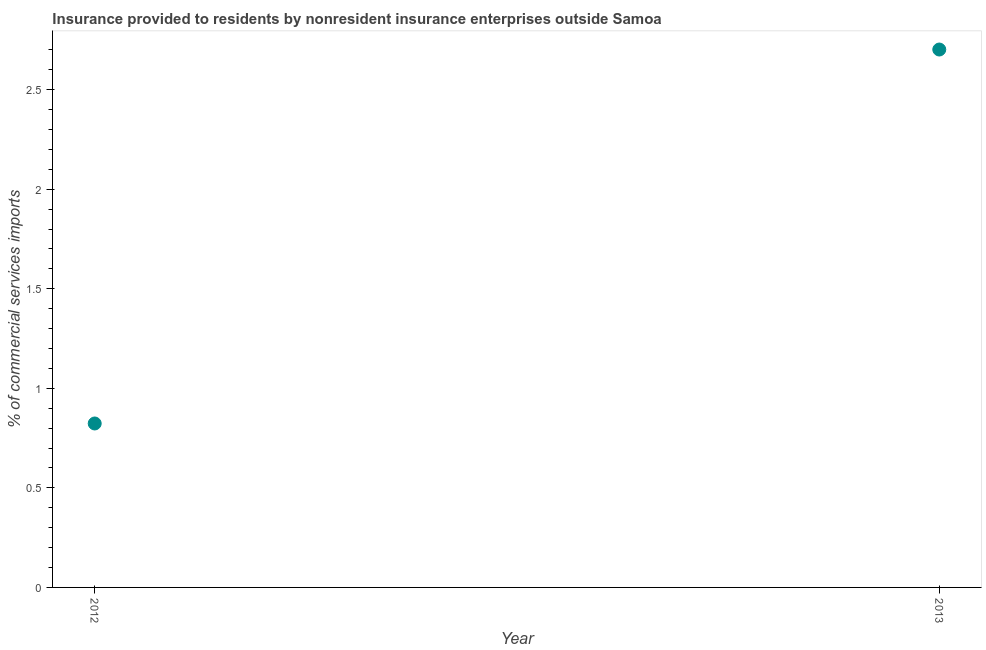What is the insurance provided by non-residents in 2013?
Keep it short and to the point. 2.7. Across all years, what is the maximum insurance provided by non-residents?
Ensure brevity in your answer.  2.7. Across all years, what is the minimum insurance provided by non-residents?
Make the answer very short. 0.82. What is the sum of the insurance provided by non-residents?
Keep it short and to the point. 3.52. What is the difference between the insurance provided by non-residents in 2012 and 2013?
Offer a terse response. -1.88. What is the average insurance provided by non-residents per year?
Offer a very short reply. 1.76. What is the median insurance provided by non-residents?
Your answer should be compact. 1.76. In how many years, is the insurance provided by non-residents greater than 1.8 %?
Ensure brevity in your answer.  1. What is the ratio of the insurance provided by non-residents in 2012 to that in 2013?
Your response must be concise. 0.3. Is the insurance provided by non-residents in 2012 less than that in 2013?
Your answer should be compact. Yes. How many years are there in the graph?
Provide a short and direct response. 2. Are the values on the major ticks of Y-axis written in scientific E-notation?
Your answer should be compact. No. Does the graph contain any zero values?
Keep it short and to the point. No. What is the title of the graph?
Give a very brief answer. Insurance provided to residents by nonresident insurance enterprises outside Samoa. What is the label or title of the X-axis?
Ensure brevity in your answer.  Year. What is the label or title of the Y-axis?
Offer a terse response. % of commercial services imports. What is the % of commercial services imports in 2012?
Provide a short and direct response. 0.82. What is the % of commercial services imports in 2013?
Your response must be concise. 2.7. What is the difference between the % of commercial services imports in 2012 and 2013?
Make the answer very short. -1.88. What is the ratio of the % of commercial services imports in 2012 to that in 2013?
Offer a terse response. 0.3. 